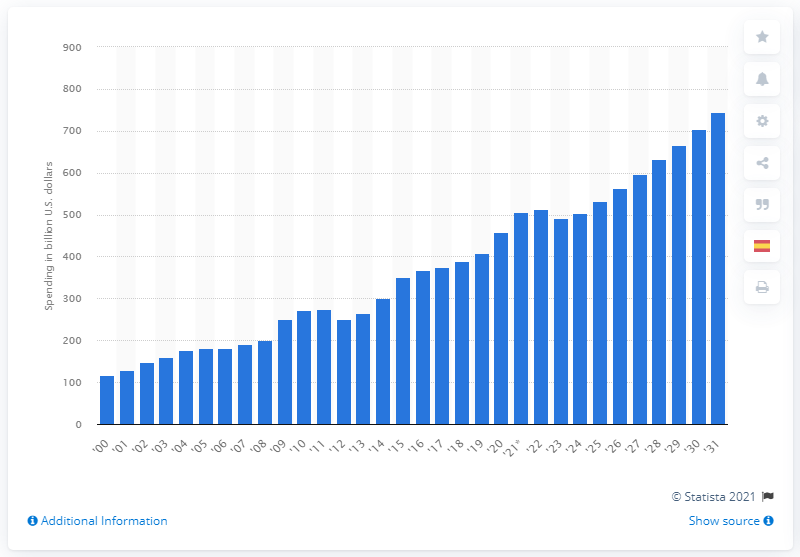Mention a couple of crucial points in this snapshot. The forecast for the increase in Medicaid outlays in 2031 is estimated to be 744. The total amount of Medicaid spending in 2020 was $458 million. 